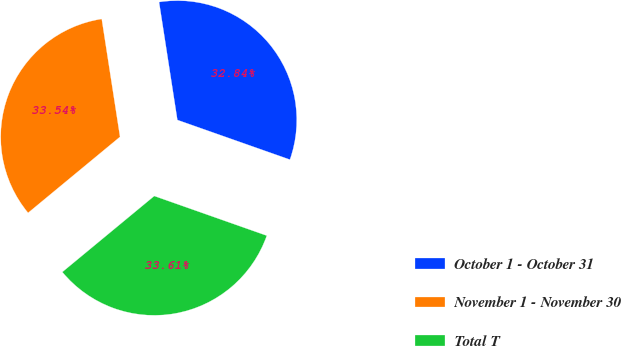Convert chart to OTSL. <chart><loc_0><loc_0><loc_500><loc_500><pie_chart><fcel>October 1 - October 31<fcel>November 1 - November 30<fcel>Total T<nl><fcel>32.84%<fcel>33.54%<fcel>33.61%<nl></chart> 